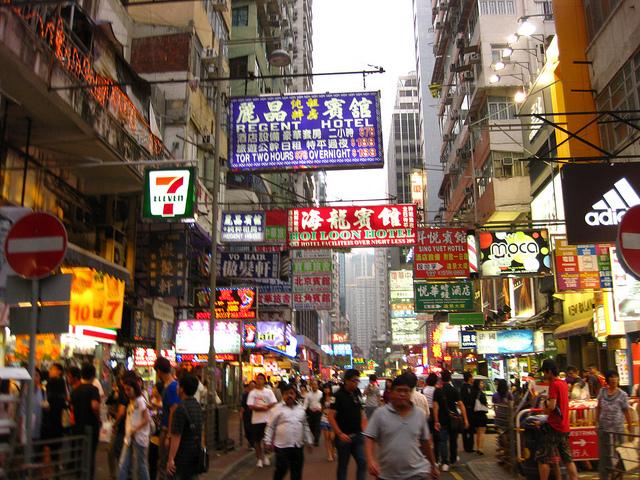How many people are shown?
Write a very short answer. 100. What language are these signs printed in?
Be succinct. Chinese. Does the woman in the lower left have long or short hair?
Be succinct. Short. Is it night time?
Give a very brief answer. No. Are there people wearing helmets?
Be succinct. No. Is it day time?
Give a very brief answer. Yes. Is this a busy street?
Be succinct. Yes. 